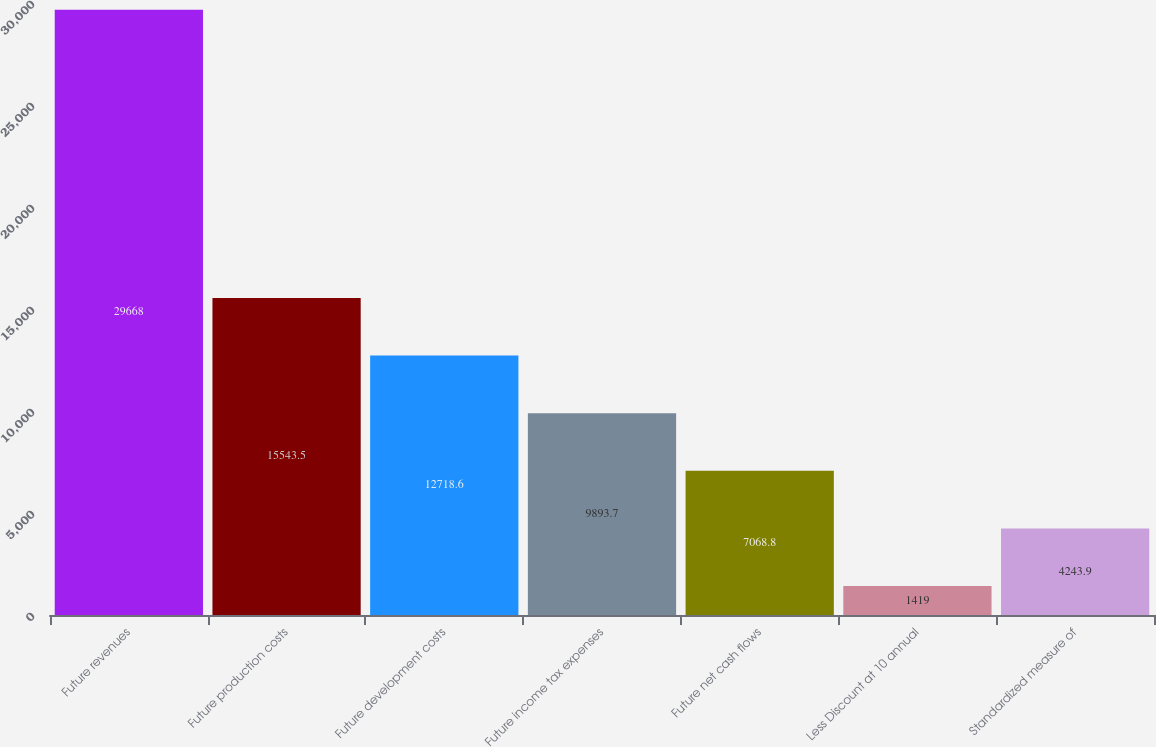Convert chart to OTSL. <chart><loc_0><loc_0><loc_500><loc_500><bar_chart><fcel>Future revenues<fcel>Future production costs<fcel>Future development costs<fcel>Future income tax expenses<fcel>Future net cash flows<fcel>Less Discount at 10 annual<fcel>Standardized measure of<nl><fcel>29668<fcel>15543.5<fcel>12718.6<fcel>9893.7<fcel>7068.8<fcel>1419<fcel>4243.9<nl></chart> 